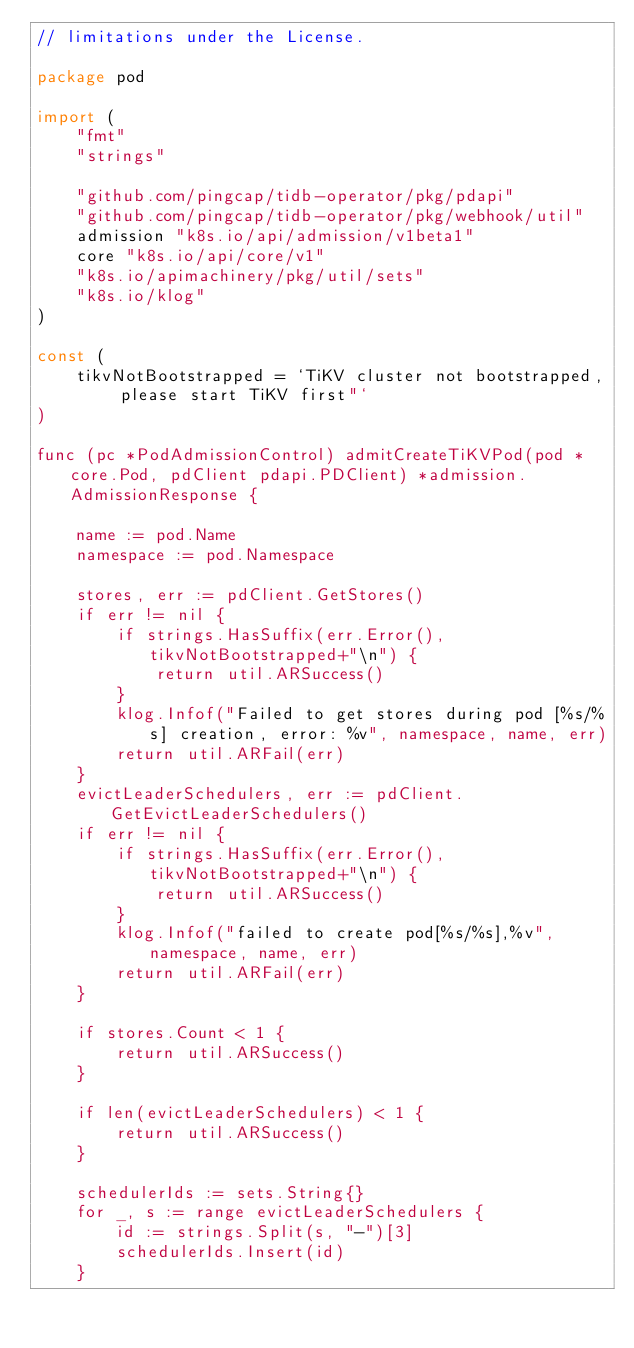<code> <loc_0><loc_0><loc_500><loc_500><_Go_>// limitations under the License.

package pod

import (
	"fmt"
	"strings"

	"github.com/pingcap/tidb-operator/pkg/pdapi"
	"github.com/pingcap/tidb-operator/pkg/webhook/util"
	admission "k8s.io/api/admission/v1beta1"
	core "k8s.io/api/core/v1"
	"k8s.io/apimachinery/pkg/util/sets"
	"k8s.io/klog"
)

const (
	tikvNotBootstrapped = `TiKV cluster not bootstrapped, please start TiKV first"`
)

func (pc *PodAdmissionControl) admitCreateTiKVPod(pod *core.Pod, pdClient pdapi.PDClient) *admission.AdmissionResponse {

	name := pod.Name
	namespace := pod.Namespace

	stores, err := pdClient.GetStores()
	if err != nil {
		if strings.HasSuffix(err.Error(), tikvNotBootstrapped+"\n") {
			return util.ARSuccess()
		}
		klog.Infof("Failed to get stores during pod [%s/%s] creation, error: %v", namespace, name, err)
		return util.ARFail(err)
	}
	evictLeaderSchedulers, err := pdClient.GetEvictLeaderSchedulers()
	if err != nil {
		if strings.HasSuffix(err.Error(), tikvNotBootstrapped+"\n") {
			return util.ARSuccess()
		}
		klog.Infof("failed to create pod[%s/%s],%v", namespace, name, err)
		return util.ARFail(err)
	}

	if stores.Count < 1 {
		return util.ARSuccess()
	}

	if len(evictLeaderSchedulers) < 1 {
		return util.ARSuccess()
	}

	schedulerIds := sets.String{}
	for _, s := range evictLeaderSchedulers {
		id := strings.Split(s, "-")[3]
		schedulerIds.Insert(id)
	}
</code> 